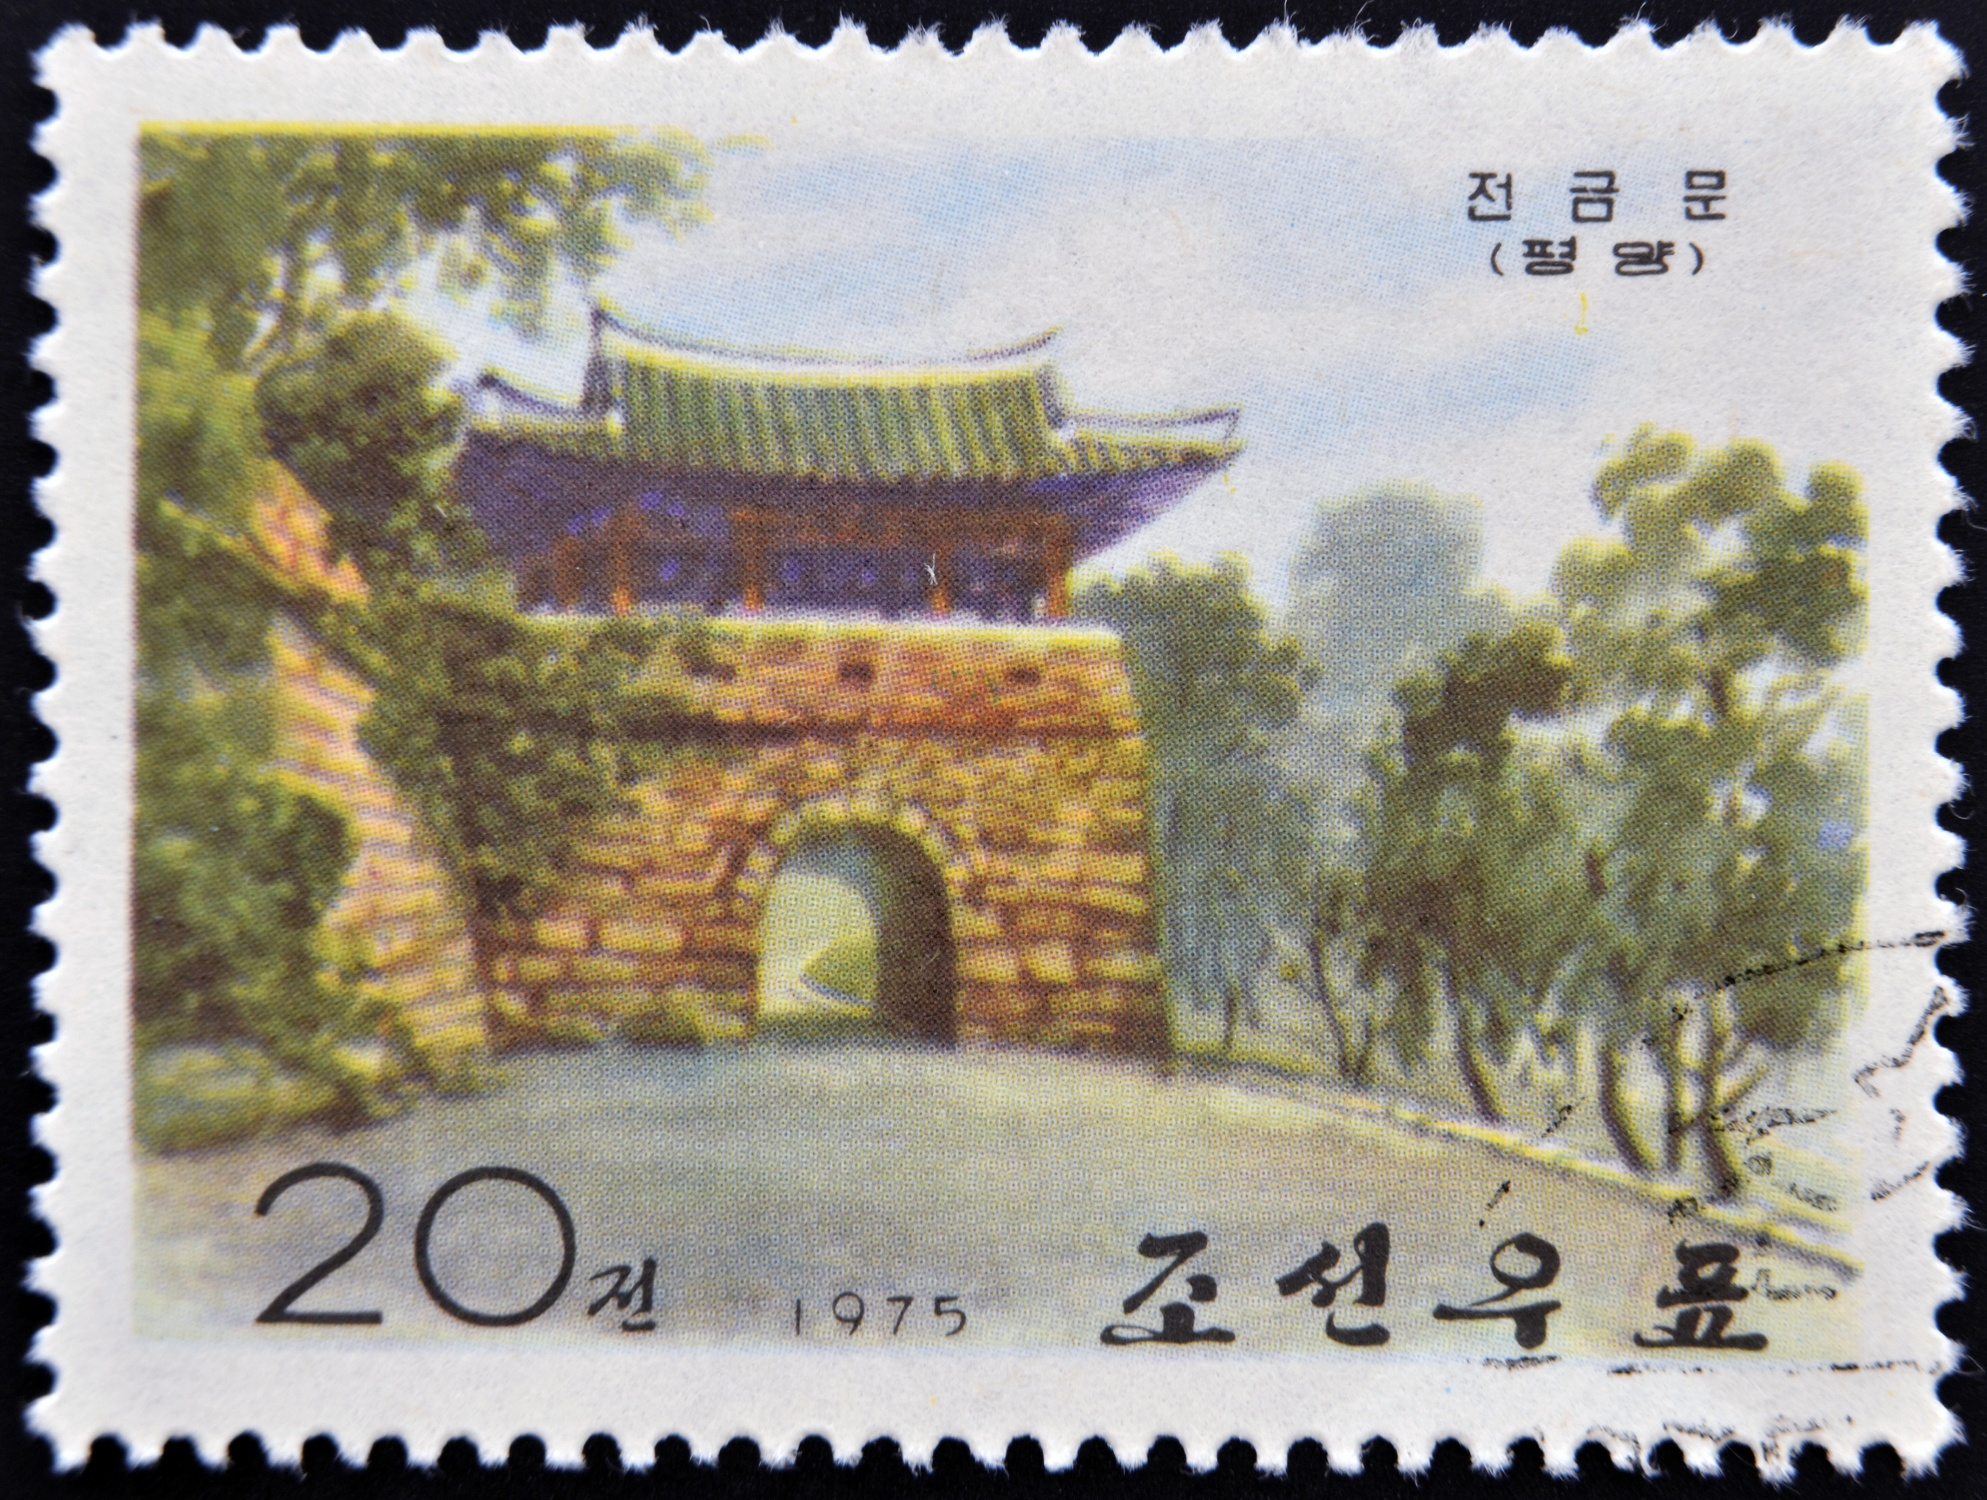Imagine walking through the gate depicted in the image. Describe the experience. As you walk through the ancient brick gate, you are immediately enveloped by a sense of history and tranquility. The soft rustling of leaves from the surrounding trees and the gentle chirping of birds create a serene atmosphere. The cool shade provided by the arched structure and the meticulously crafted green roof with its upturned eaves offer a moment of respite from the sun. You feel a connection with the past, imagining the many people who have passed through this gate over the centuries. The lush garden surrounding the gate adds to the peacefulness, with vibrant greenery and the subtle scent of blooming flowers filling the air. This walk, through a piece of preserved history, is both calming and awe-inspiring, providing a direct link to the rich cultural heritage of Korea. 